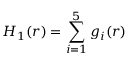<formula> <loc_0><loc_0><loc_500><loc_500>H _ { 1 } ( r ) = \sum _ { i = 1 } ^ { 5 } g _ { i } ( r )</formula> 